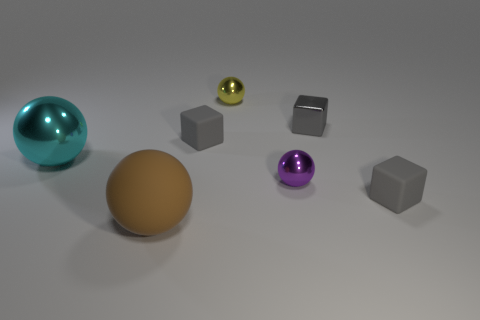What number of tiny green rubber blocks are there? There are no green rubber blocks in the image. The image contains a collection of differently colored and shaped objects, with spheres and cubes in various hues, but none of the items are tiny green rubber blocks. 